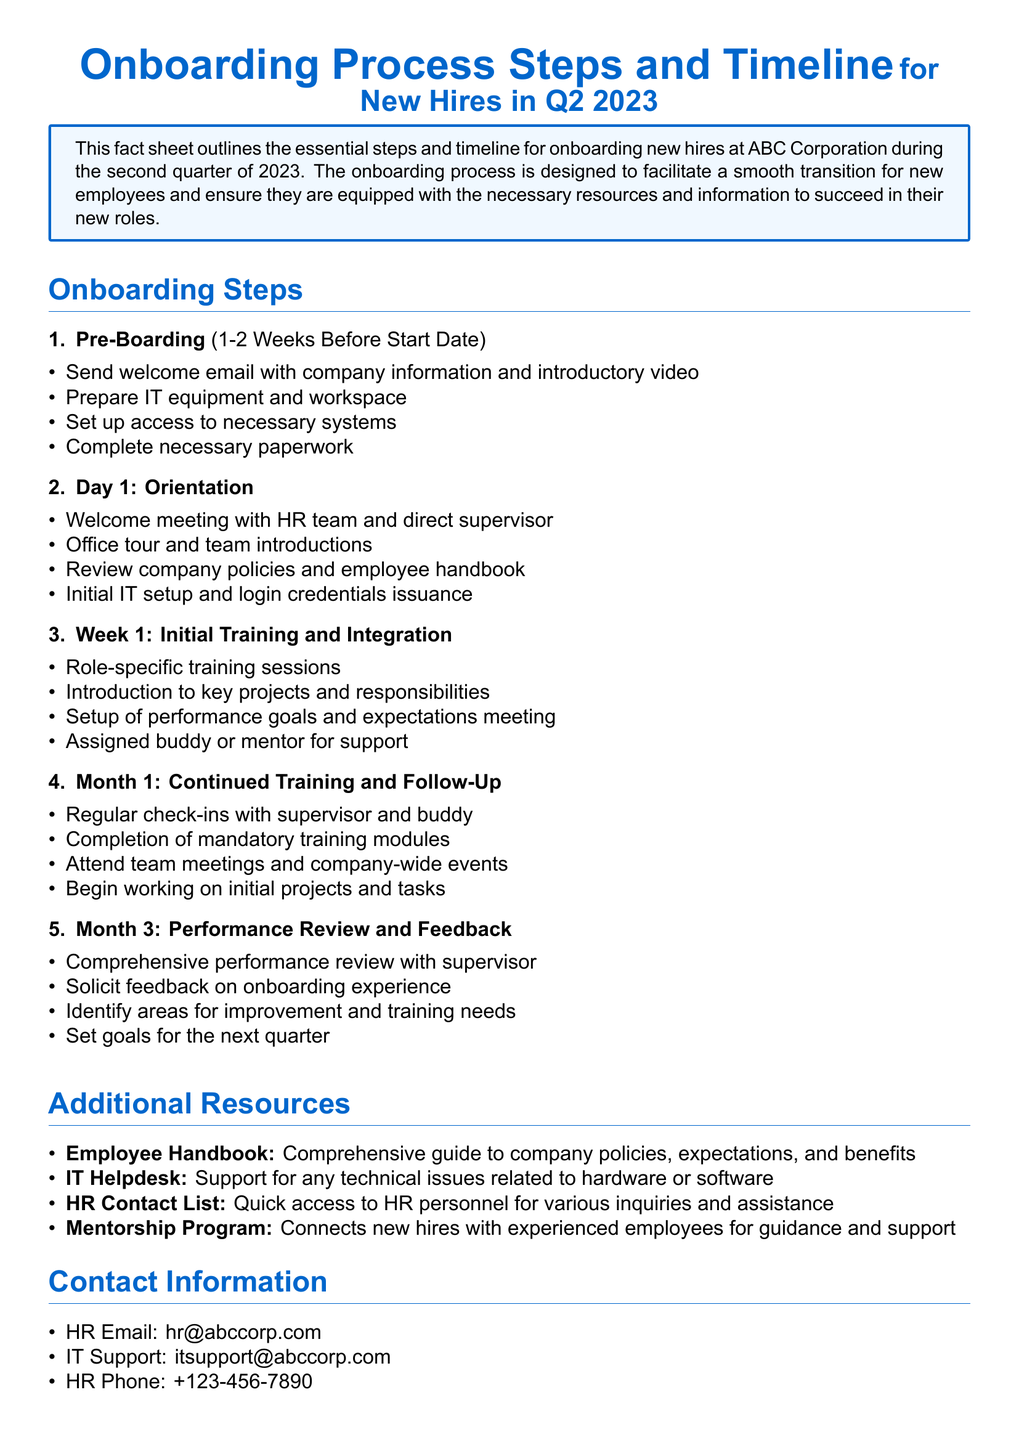What is the title of the document? The title of the document is prominently displayed at the top, indicating the topic it covers.
Answer: Onboarding Process Steps and Timeline for New Hires in Q2 2023 What is the duration of the pre-boarding step? The document specifies the duration for the pre-boarding step, indicating when it occurs in relation to the new hire's start date.
Answer: 1-2 Weeks Before Start Date What event occurs on Day 1 of onboarding? The document outlines key activities on Day 1, providing insight into the orientation process.
Answer: Orientation What type of training occurs in Month 1 of onboarding? The document provides information about the nature of training during the first month, referring to specific training types for new hires.
Answer: Continued Training Who are new hires assigned for support during Week 1? The document highlights the support system in place for new employees during their initial week, which includes mentorship.
Answer: Buddy or mentor What kind of review is conducted in Month 3? The document specifies an assessment activity occurring in the third month that evaluates performance.
Answer: Comprehensive performance review Which email address should be used for HR inquiries? The document lists contact information for HR, including email for inquiries from new hires.
Answer: hr@abccorp.com What is one additional resource provided for new hires? The document includes multiple resources available to assist new employees, detailing what they can reference for support.
Answer: Employee Handbook What will be solicited during the performance review? The document indicates that feedback is an important part of the performance review process, highlighting its relevance in onboarding.
Answer: Feedback on onboarding experience 